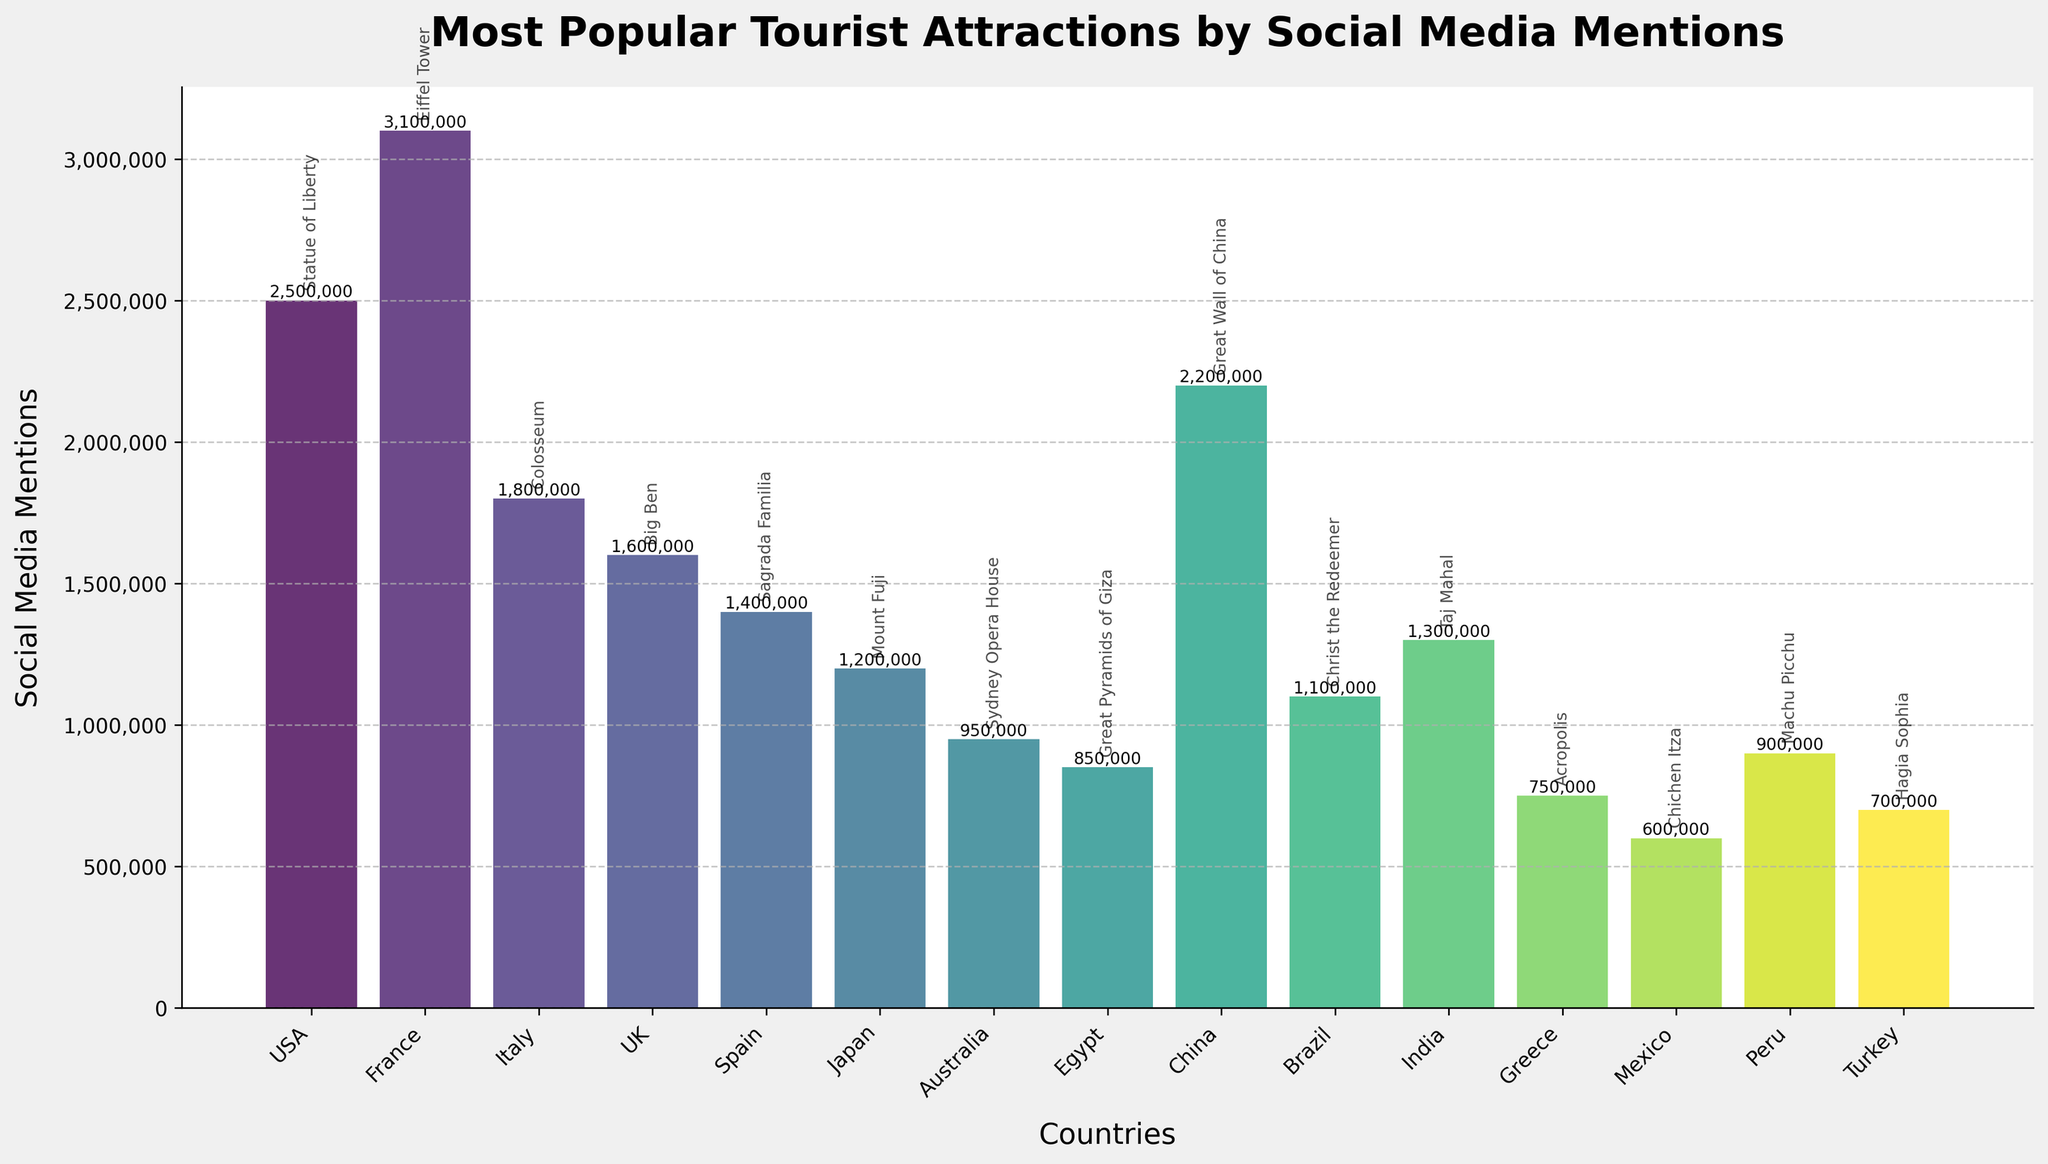Which tourist attraction has the highest number of social media mentions? The bar for France shows the highest value with 3,100,000 mentions.
Answer: Eiffel Tower Which country has fewer social media mentions for their attraction: Australia or Brazil? The bar for Australia shows 950,000 mentions, while the bar for Brazil shows 1,100,000 mentions.
Answer: Australia What is the total number of social media mentions for the attractions in USA and China combined? The USA attraction has 2,500,000 mentions, and the China attraction has 2,200,000 mentions. Sum them up: 2,500,000 + 2,200,000 = 4,700,000
Answer: 4,700,000 Which two countries have attractions with the closest number of social media mentions? The bars for UK (1,600,000) and Spain (1,400,000) are closest in height. Calculate the difference: 1,600,000 - 1,400,000 = 200,000
Answer: UK and Spain Is the mention count for the Eiffel Tower higher or lower than the combined mentions for the Great Wall of China and the Statue of Liberty? Eiffel Tower has 3,100,000 mentions. Combined mentions for the Great Wall of China (2,200,000) and the Statue of Liberty (2,500,000) is 4,700,000. 3,100,000 < 4,700,000
Answer: Lower How many attractions have more than 1,000,000 mentions? Multiple bars surpass the 1,000,000 mentions mark: USA, France, Italy, UK, Spain, China, Japan, and Brazil - totaling to 8 attractions.
Answer: 8 Which attraction has the highest number of mentions in Asia? Among the Asian countries (Japan, China, India), China has the highest mention count with 2,200,000 mentions for the Great Wall of China.
Answer: Great Wall of China What's the difference in social media mentions between the most and least popular attractions? The most popular is Eiffel Tower with 3,100,000 mentions and the least popular is Chichen Itza with 600,000 mentions. Difference: 3,100,000 - 600,000 = 2,500,000
Answer: 2,500,000 Which continent features the attraction with the second-highest number of mentions? The second-highest number of mentions is the Statue of Liberty (USA) with 2,500,000 mentions, located in North America.
Answer: North America 